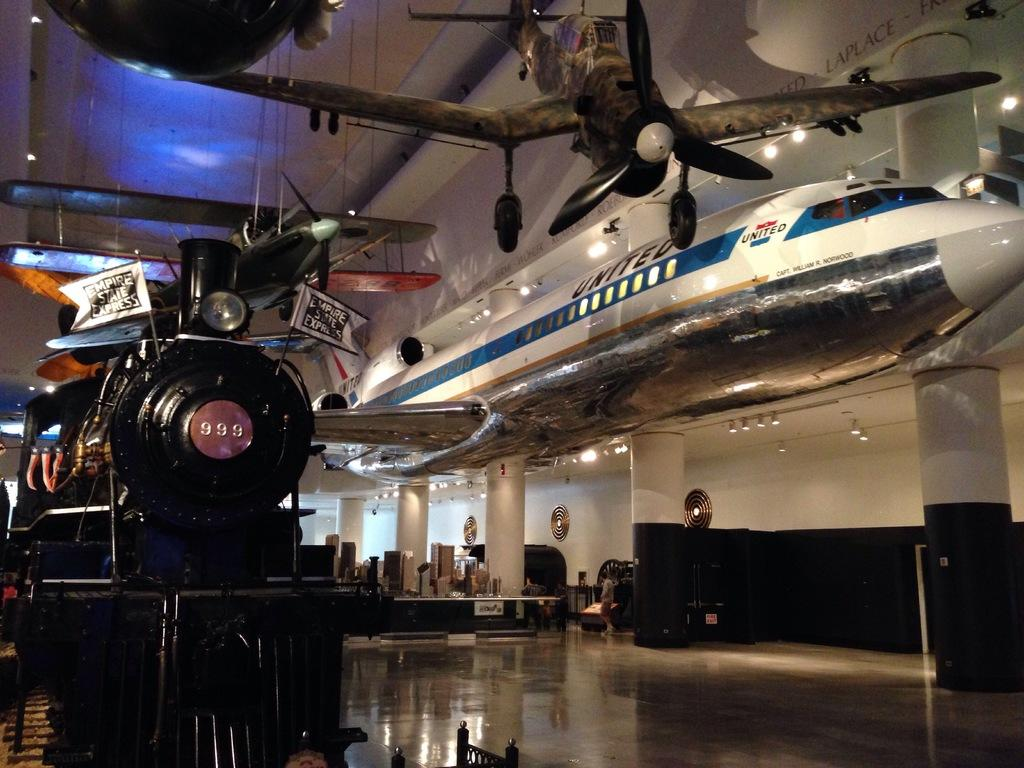<image>
Summarize the visual content of the image. A black steam engine train with 999 in the center of its front is among airplanes hanging from the ceiling. 